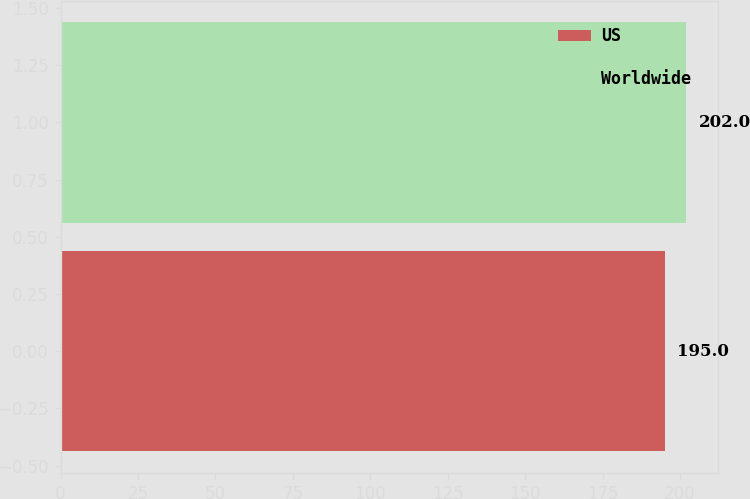Convert chart. <chart><loc_0><loc_0><loc_500><loc_500><bar_chart><fcel>US<fcel>Worldwide<nl><fcel>195<fcel>202<nl></chart> 